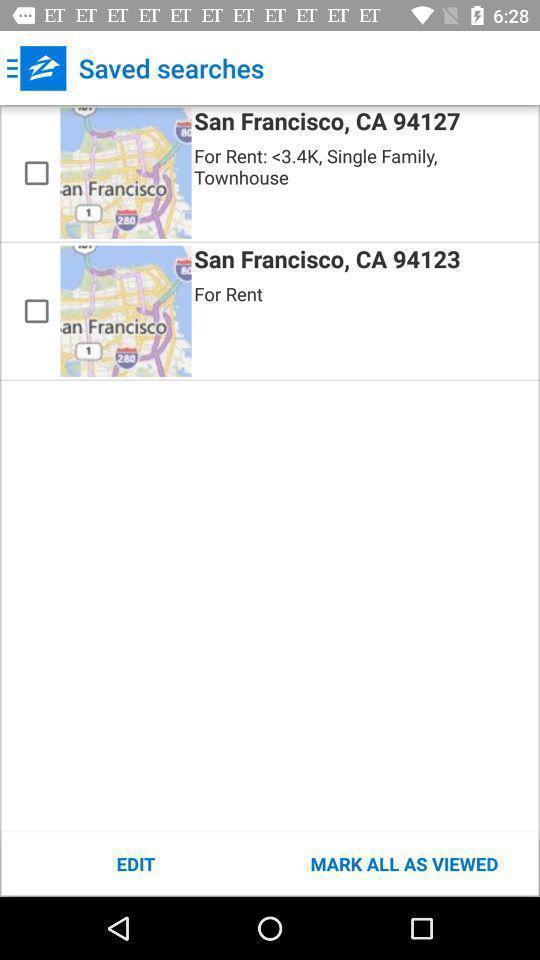Give me a narrative description of this picture. Screen display saved searches page of app. 